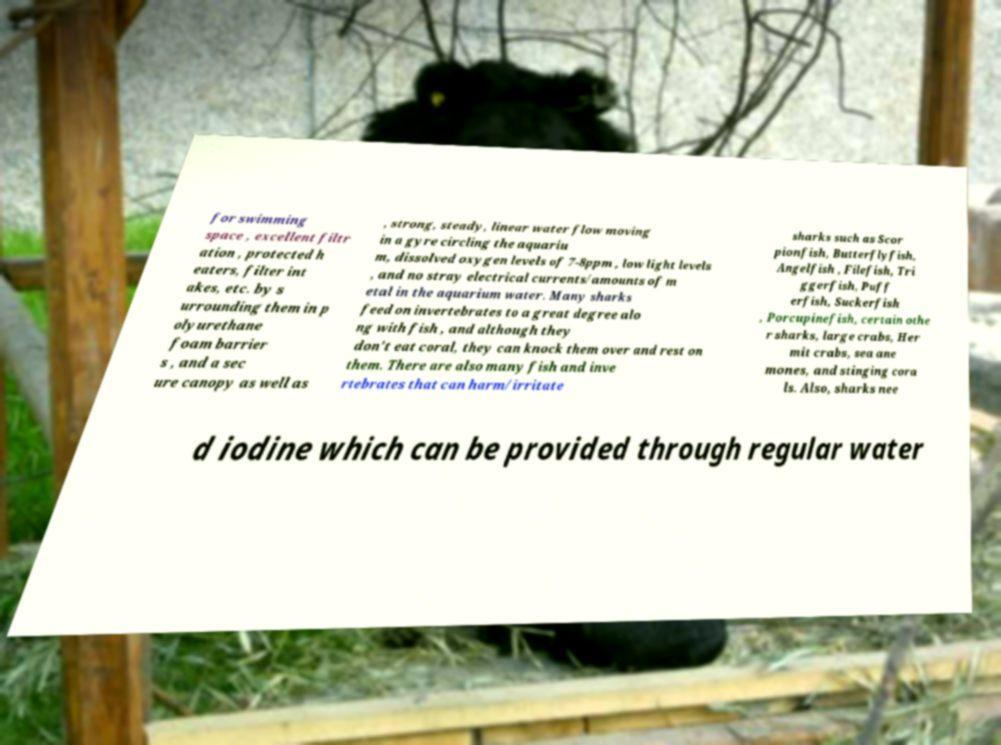Can you read and provide the text displayed in the image?This photo seems to have some interesting text. Can you extract and type it out for me? for swimming space , excellent filtr ation , protected h eaters, filter int akes, etc. by s urrounding them in p olyurethane foam barrier s , and a sec ure canopy as well as , strong, steady, linear water flow moving in a gyre circling the aquariu m, dissolved oxygen levels of 7-8ppm , low light levels , and no stray electrical currents/amounts of m etal in the aquarium water. Many sharks feed on invertebrates to a great degree alo ng with fish , and although they don't eat coral, they can knock them over and rest on them. There are also many fish and inve rtebrates that can harm/irritate sharks such as Scor pionfish, Butterflyfish, Angelfish , Filefish, Tri ggerfish, Puff erfish, Suckerfish , Porcupinefish, certain othe r sharks, large crabs, Her mit crabs, sea ane mones, and stinging cora ls. Also, sharks nee d iodine which can be provided through regular water 